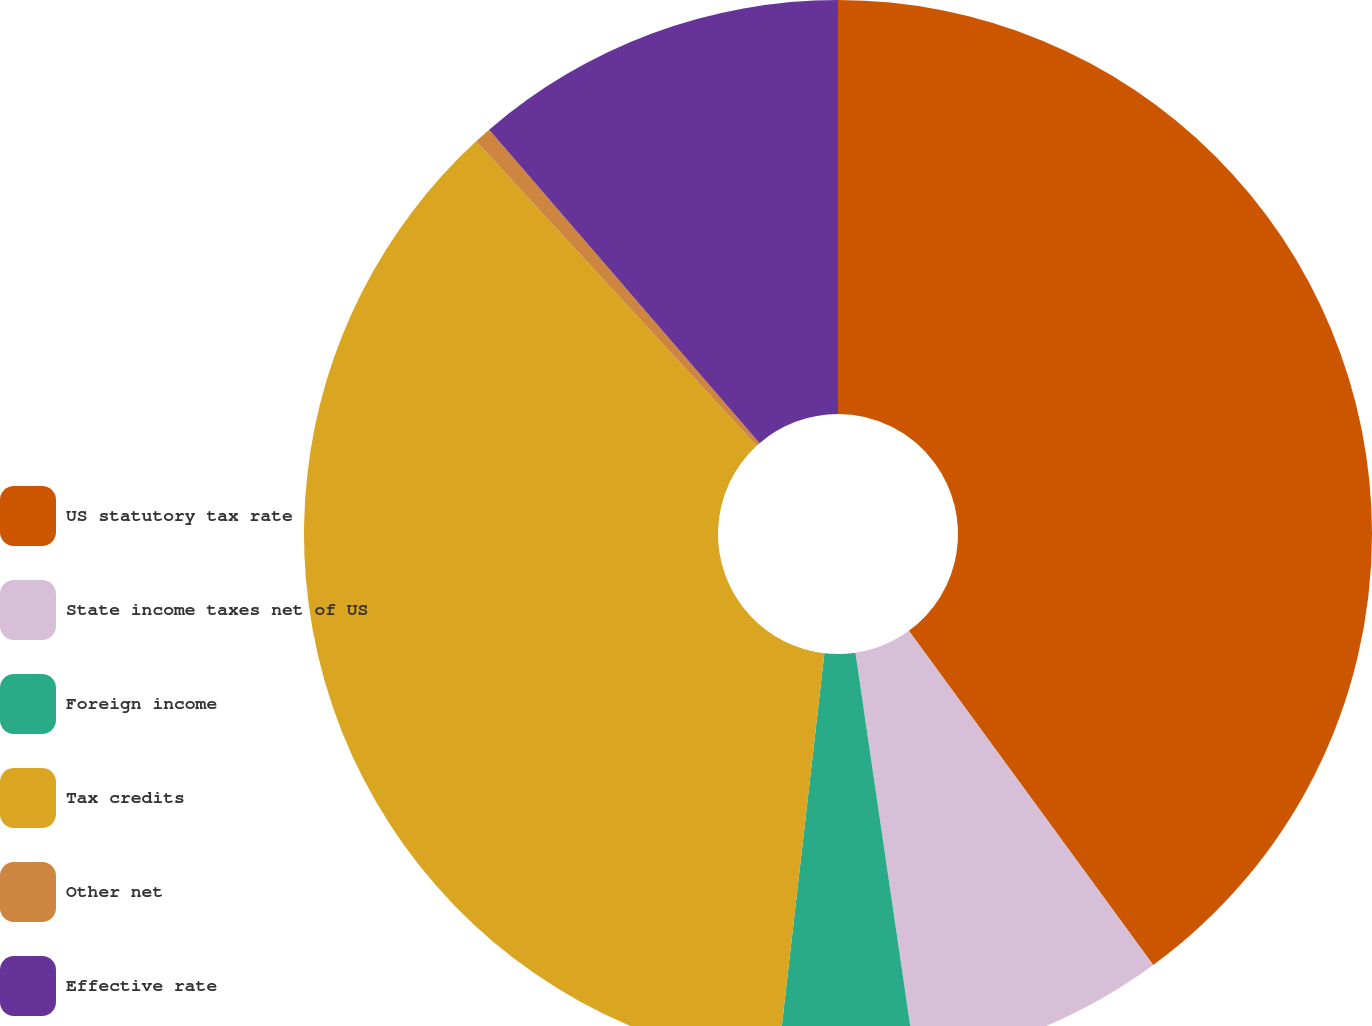Convert chart. <chart><loc_0><loc_0><loc_500><loc_500><pie_chart><fcel>US statutory tax rate<fcel>State income taxes net of US<fcel>Foreign income<fcel>Tax credits<fcel>Other net<fcel>Effective rate<nl><fcel>39.95%<fcel>7.73%<fcel>4.13%<fcel>36.34%<fcel>0.52%<fcel>11.33%<nl></chart> 